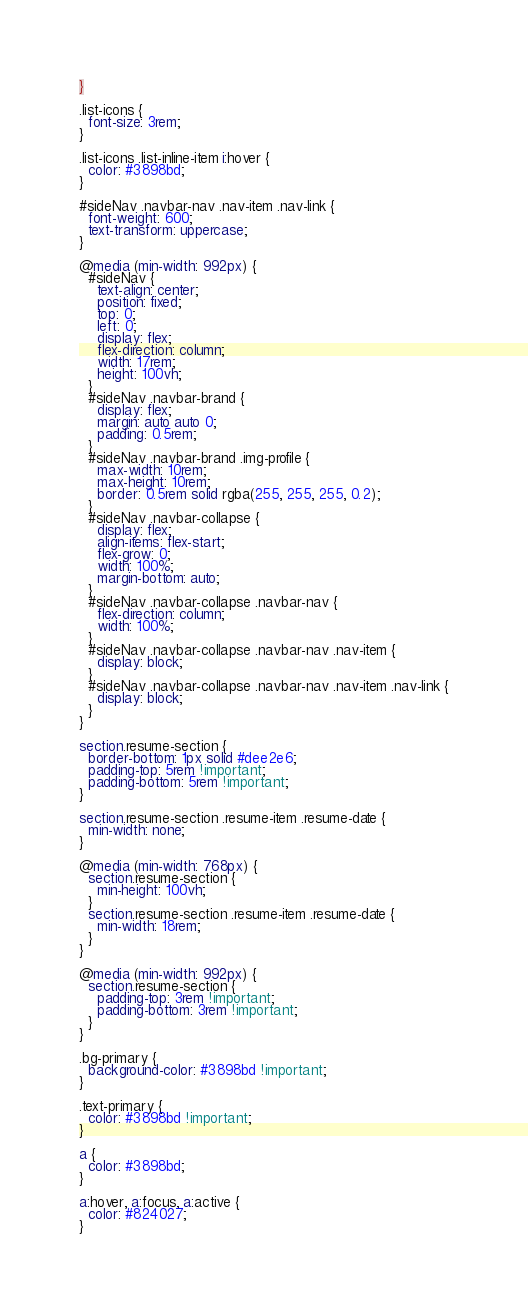Convert code to text. <code><loc_0><loc_0><loc_500><loc_500><_CSS_>}

.list-icons {
  font-size: 3rem;
}

.list-icons .list-inline-item i:hover {
  color: #3898bd;
}

#sideNav .navbar-nav .nav-item .nav-link {
  font-weight: 600;
  text-transform: uppercase;
}

@media (min-width: 992px) {
  #sideNav {
    text-align: center;
    position: fixed;
    top: 0;
    left: 0;
    display: flex;
    flex-direction: column;
    width: 17rem;
    height: 100vh;
  }
  #sideNav .navbar-brand {
    display: flex;
    margin: auto auto 0;
    padding: 0.5rem;
  }
  #sideNav .navbar-brand .img-profile {
    max-width: 10rem;
    max-height: 10rem;
    border: 0.5rem solid rgba(255, 255, 255, 0.2);
  }
  #sideNav .navbar-collapse {
    display: flex;
    align-items: flex-start;
    flex-grow: 0;
    width: 100%;
    margin-bottom: auto;
  }
  #sideNav .navbar-collapse .navbar-nav {
    flex-direction: column;
    width: 100%;
  }
  #sideNav .navbar-collapse .navbar-nav .nav-item {
    display: block;
  }
  #sideNav .navbar-collapse .navbar-nav .nav-item .nav-link {
    display: block;
  }
}

section.resume-section {
  border-bottom: 1px solid #dee2e6;
  padding-top: 5rem !important;
  padding-bottom: 5rem !important;
}

section.resume-section .resume-item .resume-date {
  min-width: none;
}

@media (min-width: 768px) {
  section.resume-section {
    min-height: 100vh;
  }
  section.resume-section .resume-item .resume-date {
    min-width: 18rem;
  }
}

@media (min-width: 992px) {
  section.resume-section {
    padding-top: 3rem !important;
    padding-bottom: 3rem !important;
  }
}

.bg-primary {
  background-color: #3898bd !important;
}

.text-primary {
  color: #3898bd !important;
}

a {
  color: #3898bd;
}

a:hover, a:focus, a:active {
  color: #824027;
}
</code> 